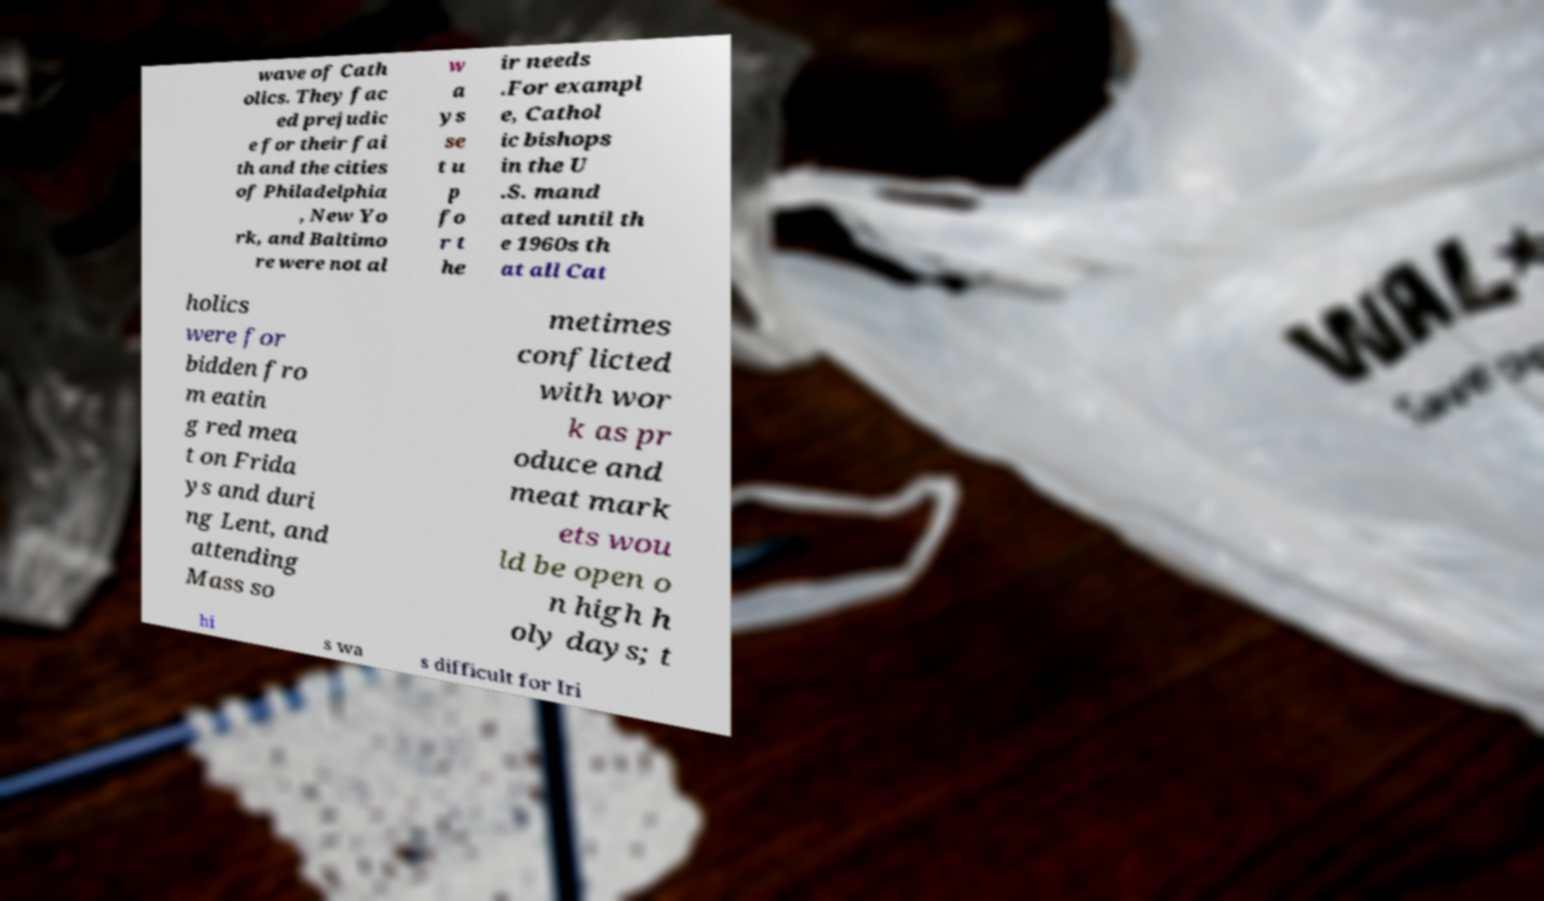There's text embedded in this image that I need extracted. Can you transcribe it verbatim? wave of Cath olics. They fac ed prejudic e for their fai th and the cities of Philadelphia , New Yo rk, and Baltimo re were not al w a ys se t u p fo r t he ir needs .For exampl e, Cathol ic bishops in the U .S. mand ated until th e 1960s th at all Cat holics were for bidden fro m eatin g red mea t on Frida ys and duri ng Lent, and attending Mass so metimes conflicted with wor k as pr oduce and meat mark ets wou ld be open o n high h oly days; t hi s wa s difficult for Iri 